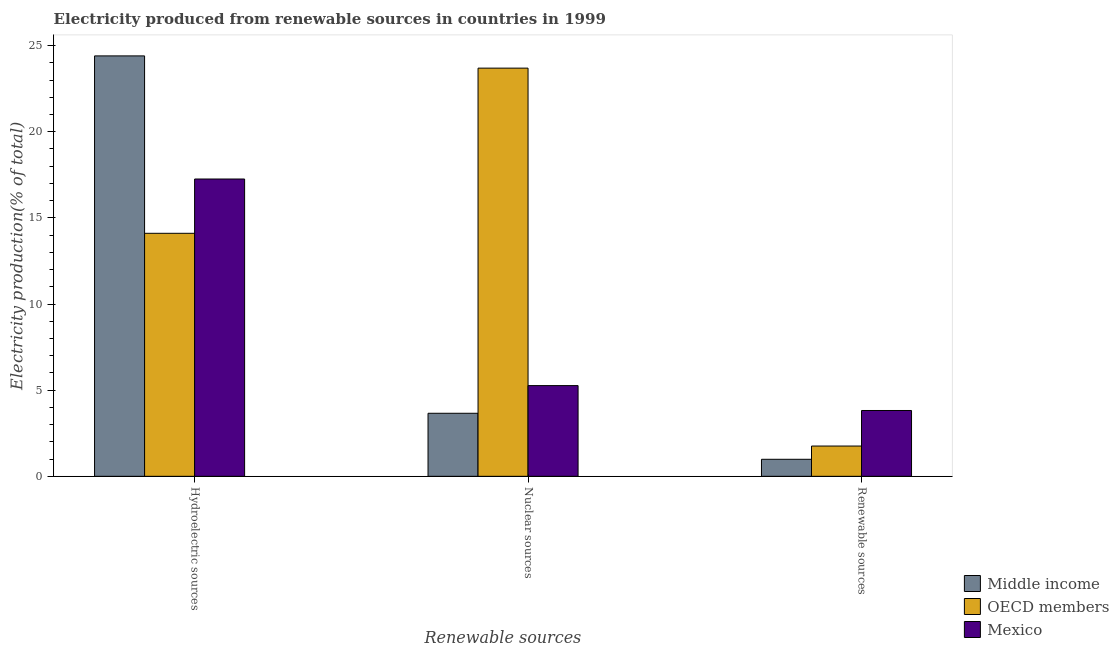How many different coloured bars are there?
Make the answer very short. 3. How many bars are there on the 1st tick from the left?
Offer a very short reply. 3. What is the label of the 1st group of bars from the left?
Provide a short and direct response. Hydroelectric sources. What is the percentage of electricity produced by renewable sources in OECD members?
Your response must be concise. 1.76. Across all countries, what is the maximum percentage of electricity produced by renewable sources?
Provide a short and direct response. 3.82. Across all countries, what is the minimum percentage of electricity produced by renewable sources?
Ensure brevity in your answer.  0.99. In which country was the percentage of electricity produced by nuclear sources maximum?
Ensure brevity in your answer.  OECD members. What is the total percentage of electricity produced by nuclear sources in the graph?
Provide a short and direct response. 32.61. What is the difference between the percentage of electricity produced by nuclear sources in Mexico and that in OECD members?
Ensure brevity in your answer.  -18.43. What is the difference between the percentage of electricity produced by renewable sources in Mexico and the percentage of electricity produced by nuclear sources in Middle income?
Give a very brief answer. 0.16. What is the average percentage of electricity produced by hydroelectric sources per country?
Offer a very short reply. 18.59. What is the difference between the percentage of electricity produced by renewable sources and percentage of electricity produced by nuclear sources in Middle income?
Offer a terse response. -2.67. In how many countries, is the percentage of electricity produced by renewable sources greater than 11 %?
Your answer should be compact. 0. What is the ratio of the percentage of electricity produced by renewable sources in Middle income to that in OECD members?
Your answer should be compact. 0.56. Is the percentage of electricity produced by nuclear sources in Mexico less than that in Middle income?
Your response must be concise. No. Is the difference between the percentage of electricity produced by hydroelectric sources in OECD members and Middle income greater than the difference between the percentage of electricity produced by nuclear sources in OECD members and Middle income?
Keep it short and to the point. No. What is the difference between the highest and the second highest percentage of electricity produced by renewable sources?
Offer a very short reply. 2.06. What is the difference between the highest and the lowest percentage of electricity produced by nuclear sources?
Provide a succinct answer. 20.03. Is the sum of the percentage of electricity produced by hydroelectric sources in Middle income and OECD members greater than the maximum percentage of electricity produced by nuclear sources across all countries?
Your response must be concise. Yes. What does the 2nd bar from the right in Nuclear sources represents?
Offer a terse response. OECD members. Is it the case that in every country, the sum of the percentage of electricity produced by hydroelectric sources and percentage of electricity produced by nuclear sources is greater than the percentage of electricity produced by renewable sources?
Keep it short and to the point. Yes. Are all the bars in the graph horizontal?
Provide a succinct answer. No. How many countries are there in the graph?
Your answer should be very brief. 3. What is the difference between two consecutive major ticks on the Y-axis?
Your answer should be compact. 5. Are the values on the major ticks of Y-axis written in scientific E-notation?
Offer a very short reply. No. Does the graph contain any zero values?
Your response must be concise. No. Where does the legend appear in the graph?
Provide a succinct answer. Bottom right. How many legend labels are there?
Your answer should be compact. 3. What is the title of the graph?
Make the answer very short. Electricity produced from renewable sources in countries in 1999. What is the label or title of the X-axis?
Your answer should be very brief. Renewable sources. What is the Electricity production(% of total) of Middle income in Hydroelectric sources?
Your response must be concise. 24.4. What is the Electricity production(% of total) in OECD members in Hydroelectric sources?
Ensure brevity in your answer.  14.1. What is the Electricity production(% of total) in Mexico in Hydroelectric sources?
Your answer should be very brief. 17.26. What is the Electricity production(% of total) of Middle income in Nuclear sources?
Ensure brevity in your answer.  3.66. What is the Electricity production(% of total) in OECD members in Nuclear sources?
Offer a very short reply. 23.69. What is the Electricity production(% of total) in Mexico in Nuclear sources?
Offer a very short reply. 5.26. What is the Electricity production(% of total) in Middle income in Renewable sources?
Your answer should be compact. 0.99. What is the Electricity production(% of total) in OECD members in Renewable sources?
Provide a succinct answer. 1.76. What is the Electricity production(% of total) of Mexico in Renewable sources?
Offer a very short reply. 3.82. Across all Renewable sources, what is the maximum Electricity production(% of total) of Middle income?
Give a very brief answer. 24.4. Across all Renewable sources, what is the maximum Electricity production(% of total) of OECD members?
Your answer should be very brief. 23.69. Across all Renewable sources, what is the maximum Electricity production(% of total) of Mexico?
Provide a succinct answer. 17.26. Across all Renewable sources, what is the minimum Electricity production(% of total) of Middle income?
Provide a succinct answer. 0.99. Across all Renewable sources, what is the minimum Electricity production(% of total) of OECD members?
Ensure brevity in your answer.  1.76. Across all Renewable sources, what is the minimum Electricity production(% of total) in Mexico?
Give a very brief answer. 3.82. What is the total Electricity production(% of total) in Middle income in the graph?
Make the answer very short. 29.05. What is the total Electricity production(% of total) in OECD members in the graph?
Your answer should be very brief. 39.55. What is the total Electricity production(% of total) in Mexico in the graph?
Provide a succinct answer. 26.34. What is the difference between the Electricity production(% of total) in Middle income in Hydroelectric sources and that in Nuclear sources?
Offer a very short reply. 20.74. What is the difference between the Electricity production(% of total) of OECD members in Hydroelectric sources and that in Nuclear sources?
Provide a short and direct response. -9.59. What is the difference between the Electricity production(% of total) of Mexico in Hydroelectric sources and that in Nuclear sources?
Provide a succinct answer. 11.99. What is the difference between the Electricity production(% of total) in Middle income in Hydroelectric sources and that in Renewable sources?
Your response must be concise. 23.41. What is the difference between the Electricity production(% of total) in OECD members in Hydroelectric sources and that in Renewable sources?
Ensure brevity in your answer.  12.35. What is the difference between the Electricity production(% of total) in Mexico in Hydroelectric sources and that in Renewable sources?
Offer a terse response. 13.44. What is the difference between the Electricity production(% of total) of Middle income in Nuclear sources and that in Renewable sources?
Your answer should be compact. 2.67. What is the difference between the Electricity production(% of total) in OECD members in Nuclear sources and that in Renewable sources?
Make the answer very short. 21.93. What is the difference between the Electricity production(% of total) in Mexico in Nuclear sources and that in Renewable sources?
Provide a succinct answer. 1.44. What is the difference between the Electricity production(% of total) in Middle income in Hydroelectric sources and the Electricity production(% of total) in OECD members in Nuclear sources?
Offer a terse response. 0.71. What is the difference between the Electricity production(% of total) of Middle income in Hydroelectric sources and the Electricity production(% of total) of Mexico in Nuclear sources?
Make the answer very short. 19.14. What is the difference between the Electricity production(% of total) of OECD members in Hydroelectric sources and the Electricity production(% of total) of Mexico in Nuclear sources?
Ensure brevity in your answer.  8.84. What is the difference between the Electricity production(% of total) of Middle income in Hydroelectric sources and the Electricity production(% of total) of OECD members in Renewable sources?
Make the answer very short. 22.64. What is the difference between the Electricity production(% of total) in Middle income in Hydroelectric sources and the Electricity production(% of total) in Mexico in Renewable sources?
Provide a succinct answer. 20.58. What is the difference between the Electricity production(% of total) of OECD members in Hydroelectric sources and the Electricity production(% of total) of Mexico in Renewable sources?
Provide a short and direct response. 10.28. What is the difference between the Electricity production(% of total) of Middle income in Nuclear sources and the Electricity production(% of total) of OECD members in Renewable sources?
Keep it short and to the point. 1.9. What is the difference between the Electricity production(% of total) in Middle income in Nuclear sources and the Electricity production(% of total) in Mexico in Renewable sources?
Your answer should be compact. -0.16. What is the difference between the Electricity production(% of total) in OECD members in Nuclear sources and the Electricity production(% of total) in Mexico in Renewable sources?
Give a very brief answer. 19.87. What is the average Electricity production(% of total) in Middle income per Renewable sources?
Offer a very short reply. 9.68. What is the average Electricity production(% of total) in OECD members per Renewable sources?
Give a very brief answer. 13.18. What is the average Electricity production(% of total) of Mexico per Renewable sources?
Provide a succinct answer. 8.78. What is the difference between the Electricity production(% of total) in Middle income and Electricity production(% of total) in OECD members in Hydroelectric sources?
Keep it short and to the point. 10.3. What is the difference between the Electricity production(% of total) in Middle income and Electricity production(% of total) in Mexico in Hydroelectric sources?
Keep it short and to the point. 7.14. What is the difference between the Electricity production(% of total) in OECD members and Electricity production(% of total) in Mexico in Hydroelectric sources?
Provide a succinct answer. -3.15. What is the difference between the Electricity production(% of total) in Middle income and Electricity production(% of total) in OECD members in Nuclear sources?
Give a very brief answer. -20.03. What is the difference between the Electricity production(% of total) of Middle income and Electricity production(% of total) of Mexico in Nuclear sources?
Give a very brief answer. -1.61. What is the difference between the Electricity production(% of total) of OECD members and Electricity production(% of total) of Mexico in Nuclear sources?
Make the answer very short. 18.43. What is the difference between the Electricity production(% of total) of Middle income and Electricity production(% of total) of OECD members in Renewable sources?
Make the answer very short. -0.77. What is the difference between the Electricity production(% of total) of Middle income and Electricity production(% of total) of Mexico in Renewable sources?
Your answer should be very brief. -2.83. What is the difference between the Electricity production(% of total) of OECD members and Electricity production(% of total) of Mexico in Renewable sources?
Provide a short and direct response. -2.06. What is the ratio of the Electricity production(% of total) in Middle income in Hydroelectric sources to that in Nuclear sources?
Provide a succinct answer. 6.67. What is the ratio of the Electricity production(% of total) in OECD members in Hydroelectric sources to that in Nuclear sources?
Offer a very short reply. 0.6. What is the ratio of the Electricity production(% of total) of Mexico in Hydroelectric sources to that in Nuclear sources?
Keep it short and to the point. 3.28. What is the ratio of the Electricity production(% of total) of Middle income in Hydroelectric sources to that in Renewable sources?
Offer a very short reply. 24.7. What is the ratio of the Electricity production(% of total) of OECD members in Hydroelectric sources to that in Renewable sources?
Ensure brevity in your answer.  8.03. What is the ratio of the Electricity production(% of total) of Mexico in Hydroelectric sources to that in Renewable sources?
Offer a very short reply. 4.52. What is the ratio of the Electricity production(% of total) in Middle income in Nuclear sources to that in Renewable sources?
Your answer should be compact. 3.7. What is the ratio of the Electricity production(% of total) of OECD members in Nuclear sources to that in Renewable sources?
Give a very brief answer. 13.48. What is the ratio of the Electricity production(% of total) of Mexico in Nuclear sources to that in Renewable sources?
Offer a terse response. 1.38. What is the difference between the highest and the second highest Electricity production(% of total) in Middle income?
Provide a succinct answer. 20.74. What is the difference between the highest and the second highest Electricity production(% of total) in OECD members?
Give a very brief answer. 9.59. What is the difference between the highest and the second highest Electricity production(% of total) in Mexico?
Make the answer very short. 11.99. What is the difference between the highest and the lowest Electricity production(% of total) of Middle income?
Give a very brief answer. 23.41. What is the difference between the highest and the lowest Electricity production(% of total) of OECD members?
Give a very brief answer. 21.93. What is the difference between the highest and the lowest Electricity production(% of total) of Mexico?
Offer a very short reply. 13.44. 